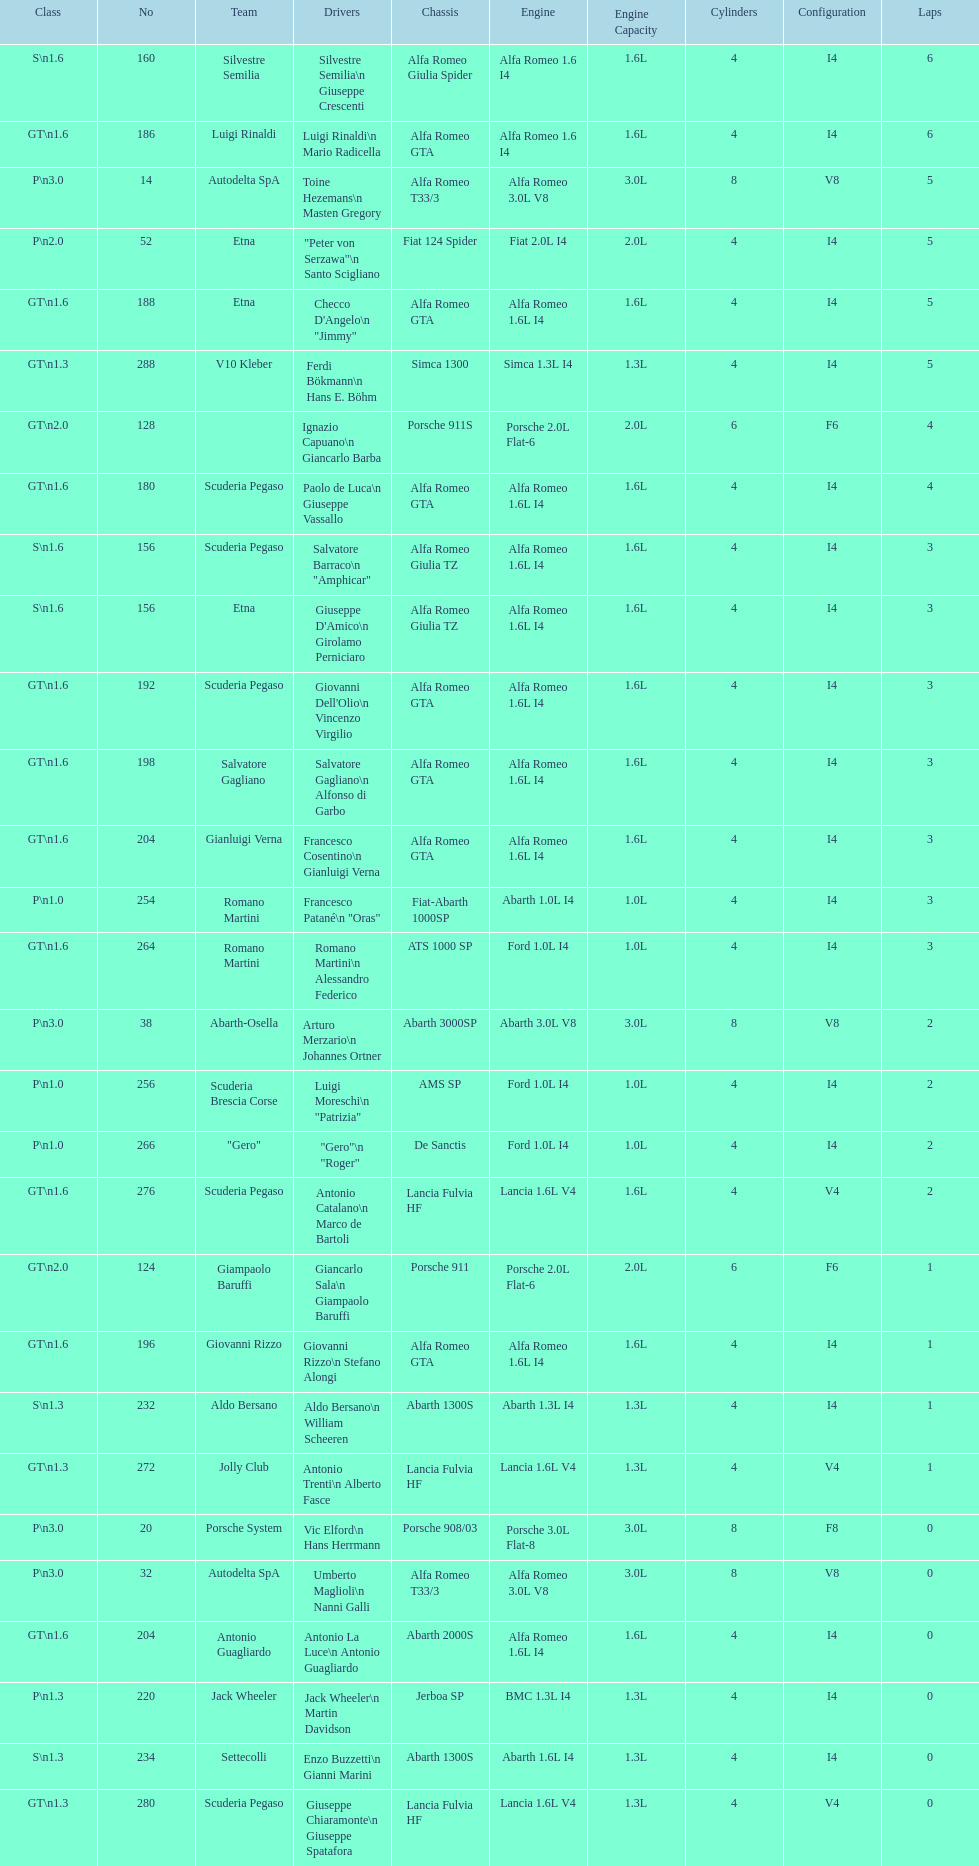How many laps does v10 kleber have? 5. 